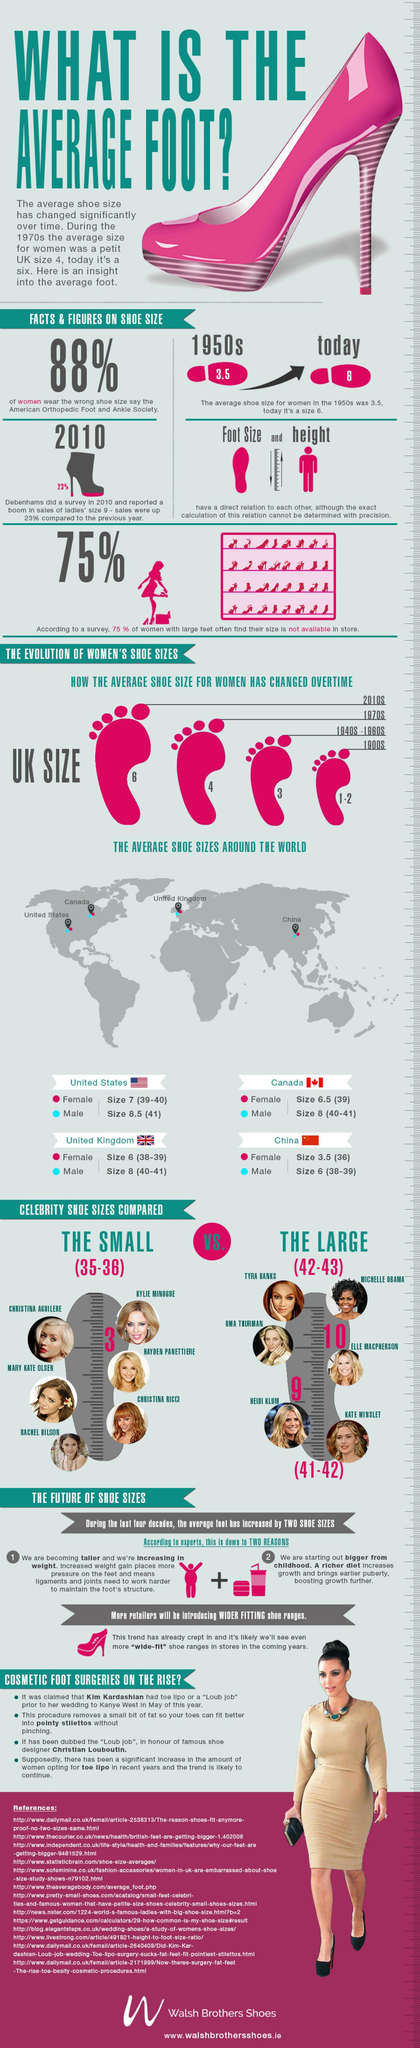What percent of women with large feet can find their size in stores?
Answer the question with a short phrase. 25% What is the average shoe size for women in 2020? 6 How many references are cited? 13 What is the shoe size of Michelle Obama- small or large? LARGE By how much has the average shoe size for women increased from 1950s to today? 2.5 What was the average UK shoe size for women during the 1970s? 4 What is the average shoe size of Rachel Bilson? 35-36 